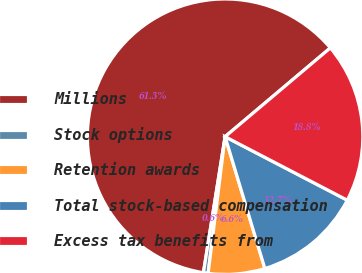Convert chart to OTSL. <chart><loc_0><loc_0><loc_500><loc_500><pie_chart><fcel>Millions<fcel>Stock options<fcel>Retention awards<fcel>Total stock-based compensation<fcel>Excess tax benefits from<nl><fcel>61.33%<fcel>0.55%<fcel>6.63%<fcel>12.71%<fcel>18.78%<nl></chart> 